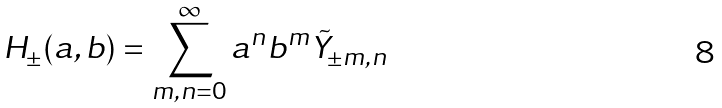<formula> <loc_0><loc_0><loc_500><loc_500>H _ { \pm } ( a , b ) = \sum _ { m , n = 0 } ^ { \infty } a ^ { n } b ^ { m } \tilde { Y } _ { \pm m , n }</formula> 